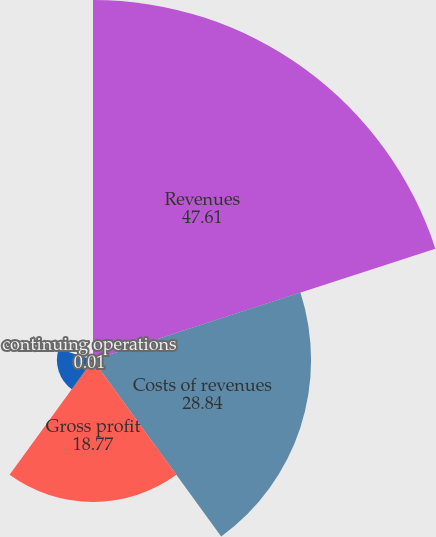<chart> <loc_0><loc_0><loc_500><loc_500><pie_chart><fcel>Revenues<fcel>Costs of revenues<fcel>Gross profit<fcel>Net earnings from continuing<fcel>continuing operations<nl><fcel>47.61%<fcel>28.84%<fcel>18.77%<fcel>4.77%<fcel>0.01%<nl></chart> 